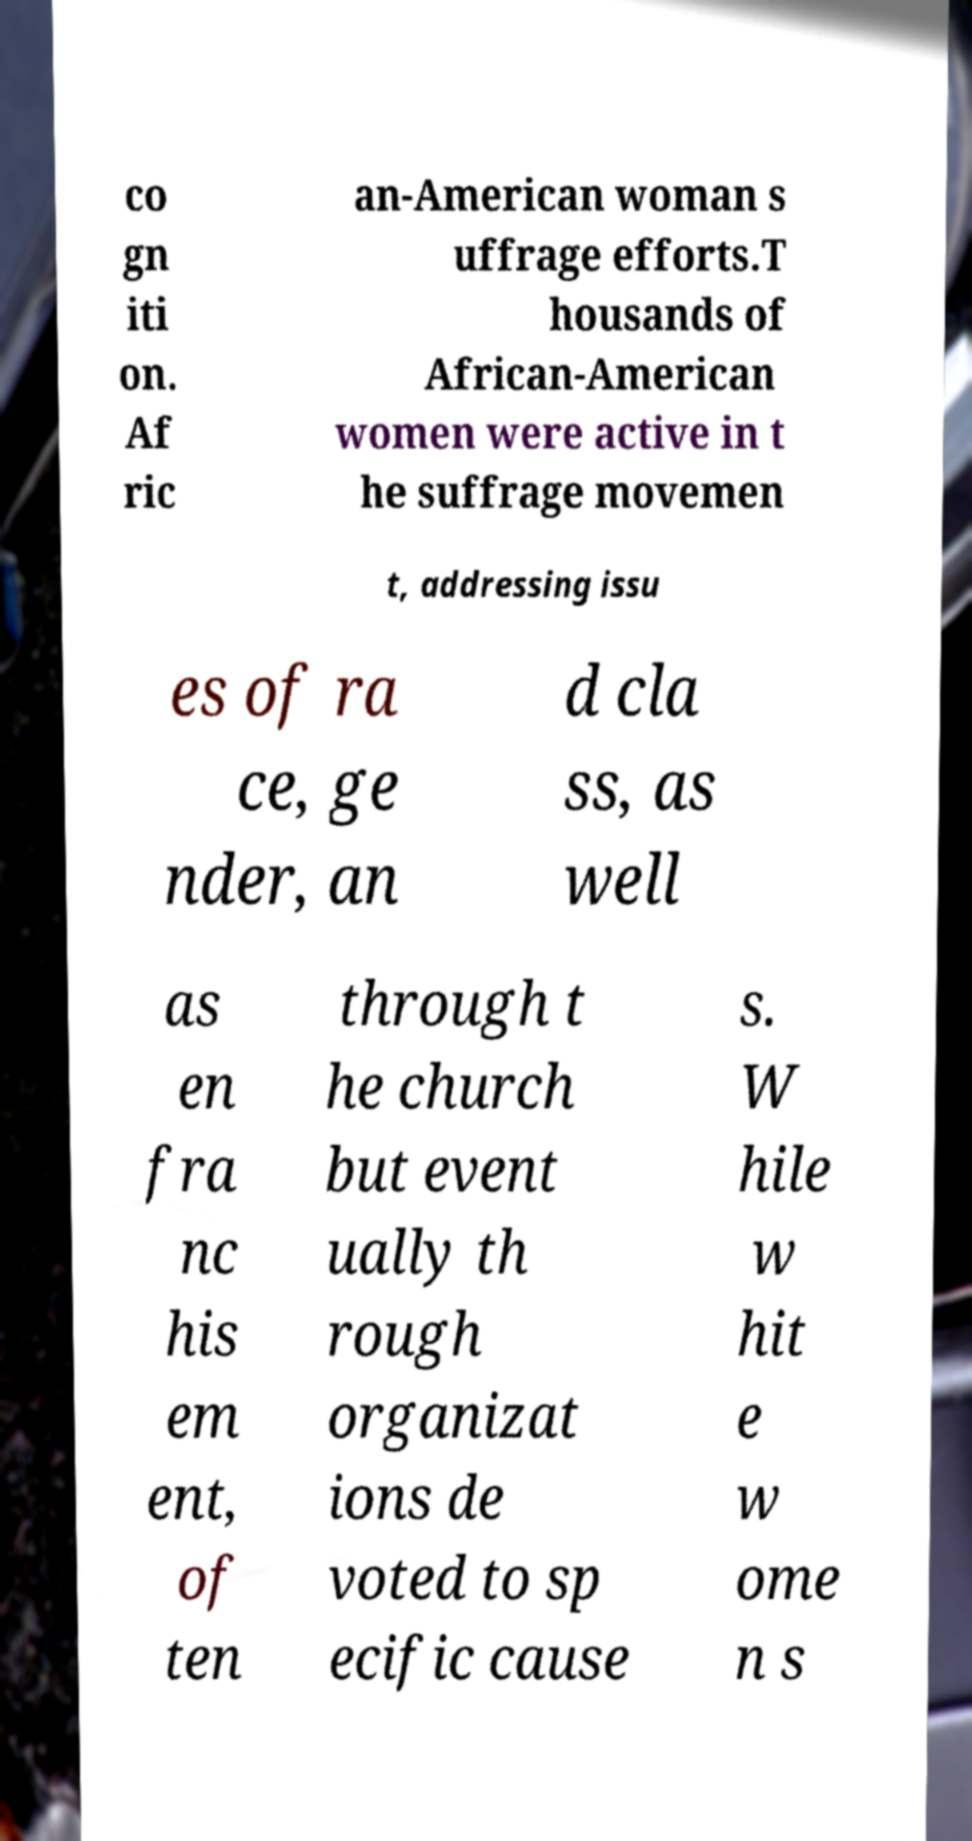There's text embedded in this image that I need extracted. Can you transcribe it verbatim? co gn iti on. Af ric an-American woman s uffrage efforts.T housands of African-American women were active in t he suffrage movemen t, addressing issu es of ra ce, ge nder, an d cla ss, as well as en fra nc his em ent, of ten through t he church but event ually th rough organizat ions de voted to sp ecific cause s. W hile w hit e w ome n s 